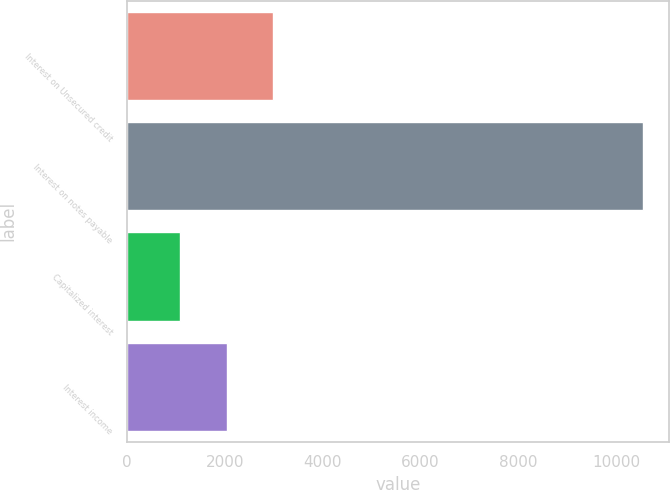<chart> <loc_0><loc_0><loc_500><loc_500><bar_chart><fcel>Interest on Unsecured credit<fcel>Interest on notes payable<fcel>Capitalized interest<fcel>Interest income<nl><fcel>2980.8<fcel>10560<fcel>1086<fcel>2033.4<nl></chart> 